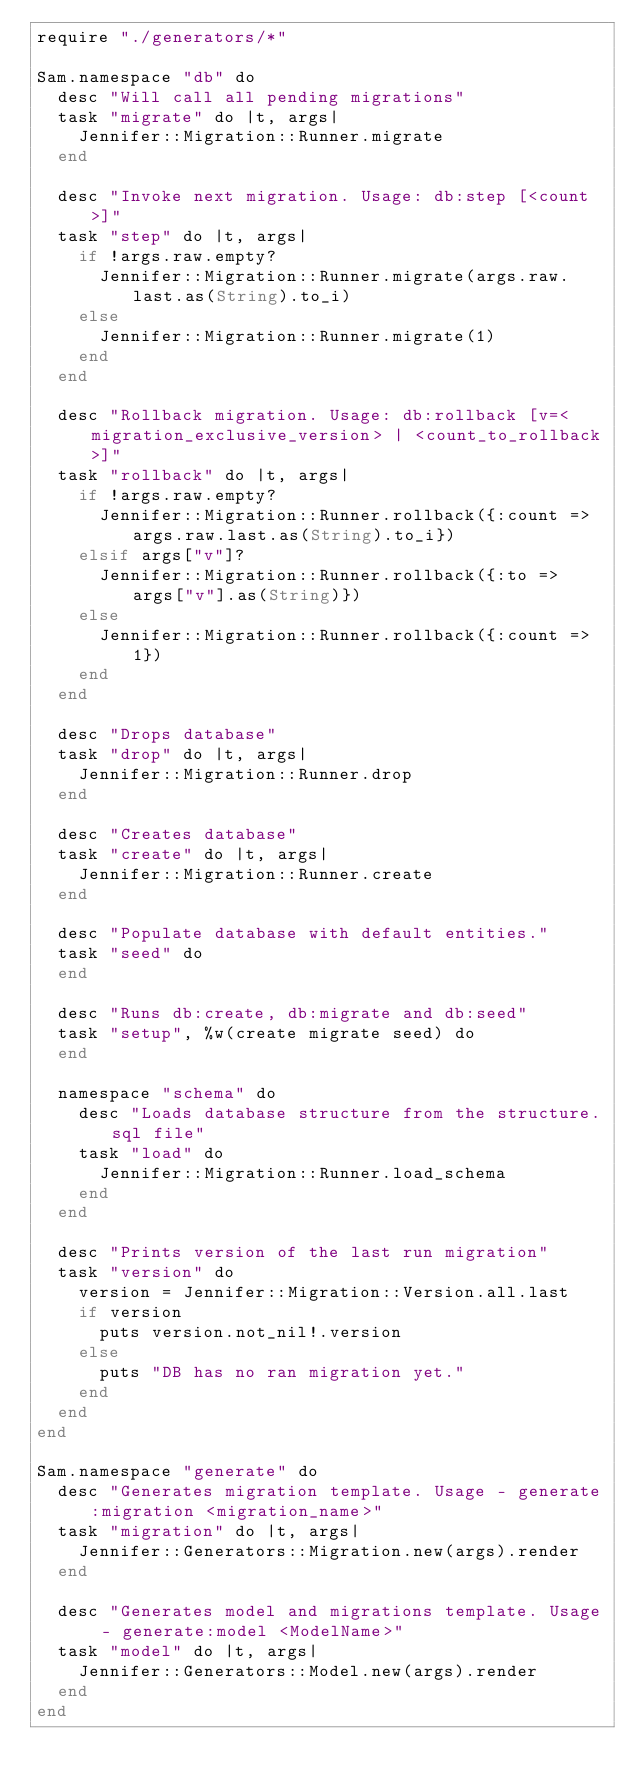<code> <loc_0><loc_0><loc_500><loc_500><_Crystal_>require "./generators/*"

Sam.namespace "db" do
  desc "Will call all pending migrations"
  task "migrate" do |t, args|
    Jennifer::Migration::Runner.migrate
  end

  desc "Invoke next migration. Usage: db:step [<count>]"
  task "step" do |t, args|
    if !args.raw.empty?
      Jennifer::Migration::Runner.migrate(args.raw.last.as(String).to_i)
    else
      Jennifer::Migration::Runner.migrate(1)
    end
  end

  desc "Rollback migration. Usage: db:rollback [v=<migration_exclusive_version> | <count_to_rollback>]"
  task "rollback" do |t, args|
    if !args.raw.empty?
      Jennifer::Migration::Runner.rollback({:count => args.raw.last.as(String).to_i})
    elsif args["v"]?
      Jennifer::Migration::Runner.rollback({:to => args["v"].as(String)})
    else
      Jennifer::Migration::Runner.rollback({:count => 1})
    end
  end

  desc "Drops database"
  task "drop" do |t, args|
    Jennifer::Migration::Runner.drop
  end

  desc "Creates database"
  task "create" do |t, args|
    Jennifer::Migration::Runner.create
  end

  desc "Populate database with default entities."
  task "seed" do
  end

  desc "Runs db:create, db:migrate and db:seed"
  task "setup", %w(create migrate seed) do
  end

  namespace "schema" do
    desc "Loads database structure from the structure.sql file"
    task "load" do
      Jennifer::Migration::Runner.load_schema
    end
  end

  desc "Prints version of the last run migration"
  task "version" do
    version = Jennifer::Migration::Version.all.last
    if version
      puts version.not_nil!.version
    else
      puts "DB has no ran migration yet."
    end
  end
end

Sam.namespace "generate" do
  desc "Generates migration template. Usage - generate:migration <migration_name>"
  task "migration" do |t, args|
    Jennifer::Generators::Migration.new(args).render
  end

  desc "Generates model and migrations template. Usage - generate:model <ModelName>"
  task "model" do |t, args|
    Jennifer::Generators::Model.new(args).render
  end
end
</code> 